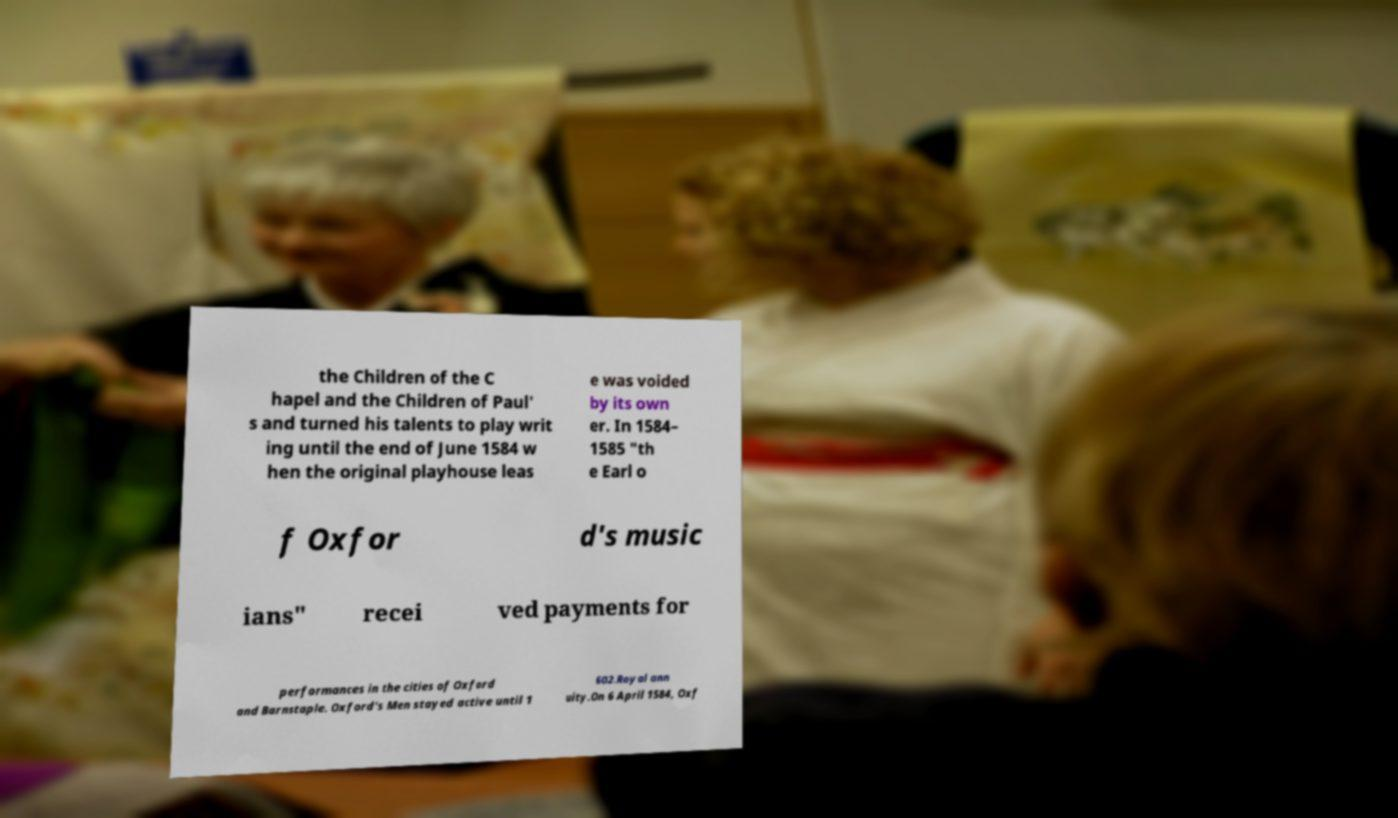Can you accurately transcribe the text from the provided image for me? the Children of the C hapel and the Children of Paul' s and turned his talents to play writ ing until the end of June 1584 w hen the original playhouse leas e was voided by its own er. In 1584– 1585 "th e Earl o f Oxfor d's music ians" recei ved payments for performances in the cities of Oxford and Barnstaple. Oxford's Men stayed active until 1 602.Royal ann uity.On 6 April 1584, Oxf 